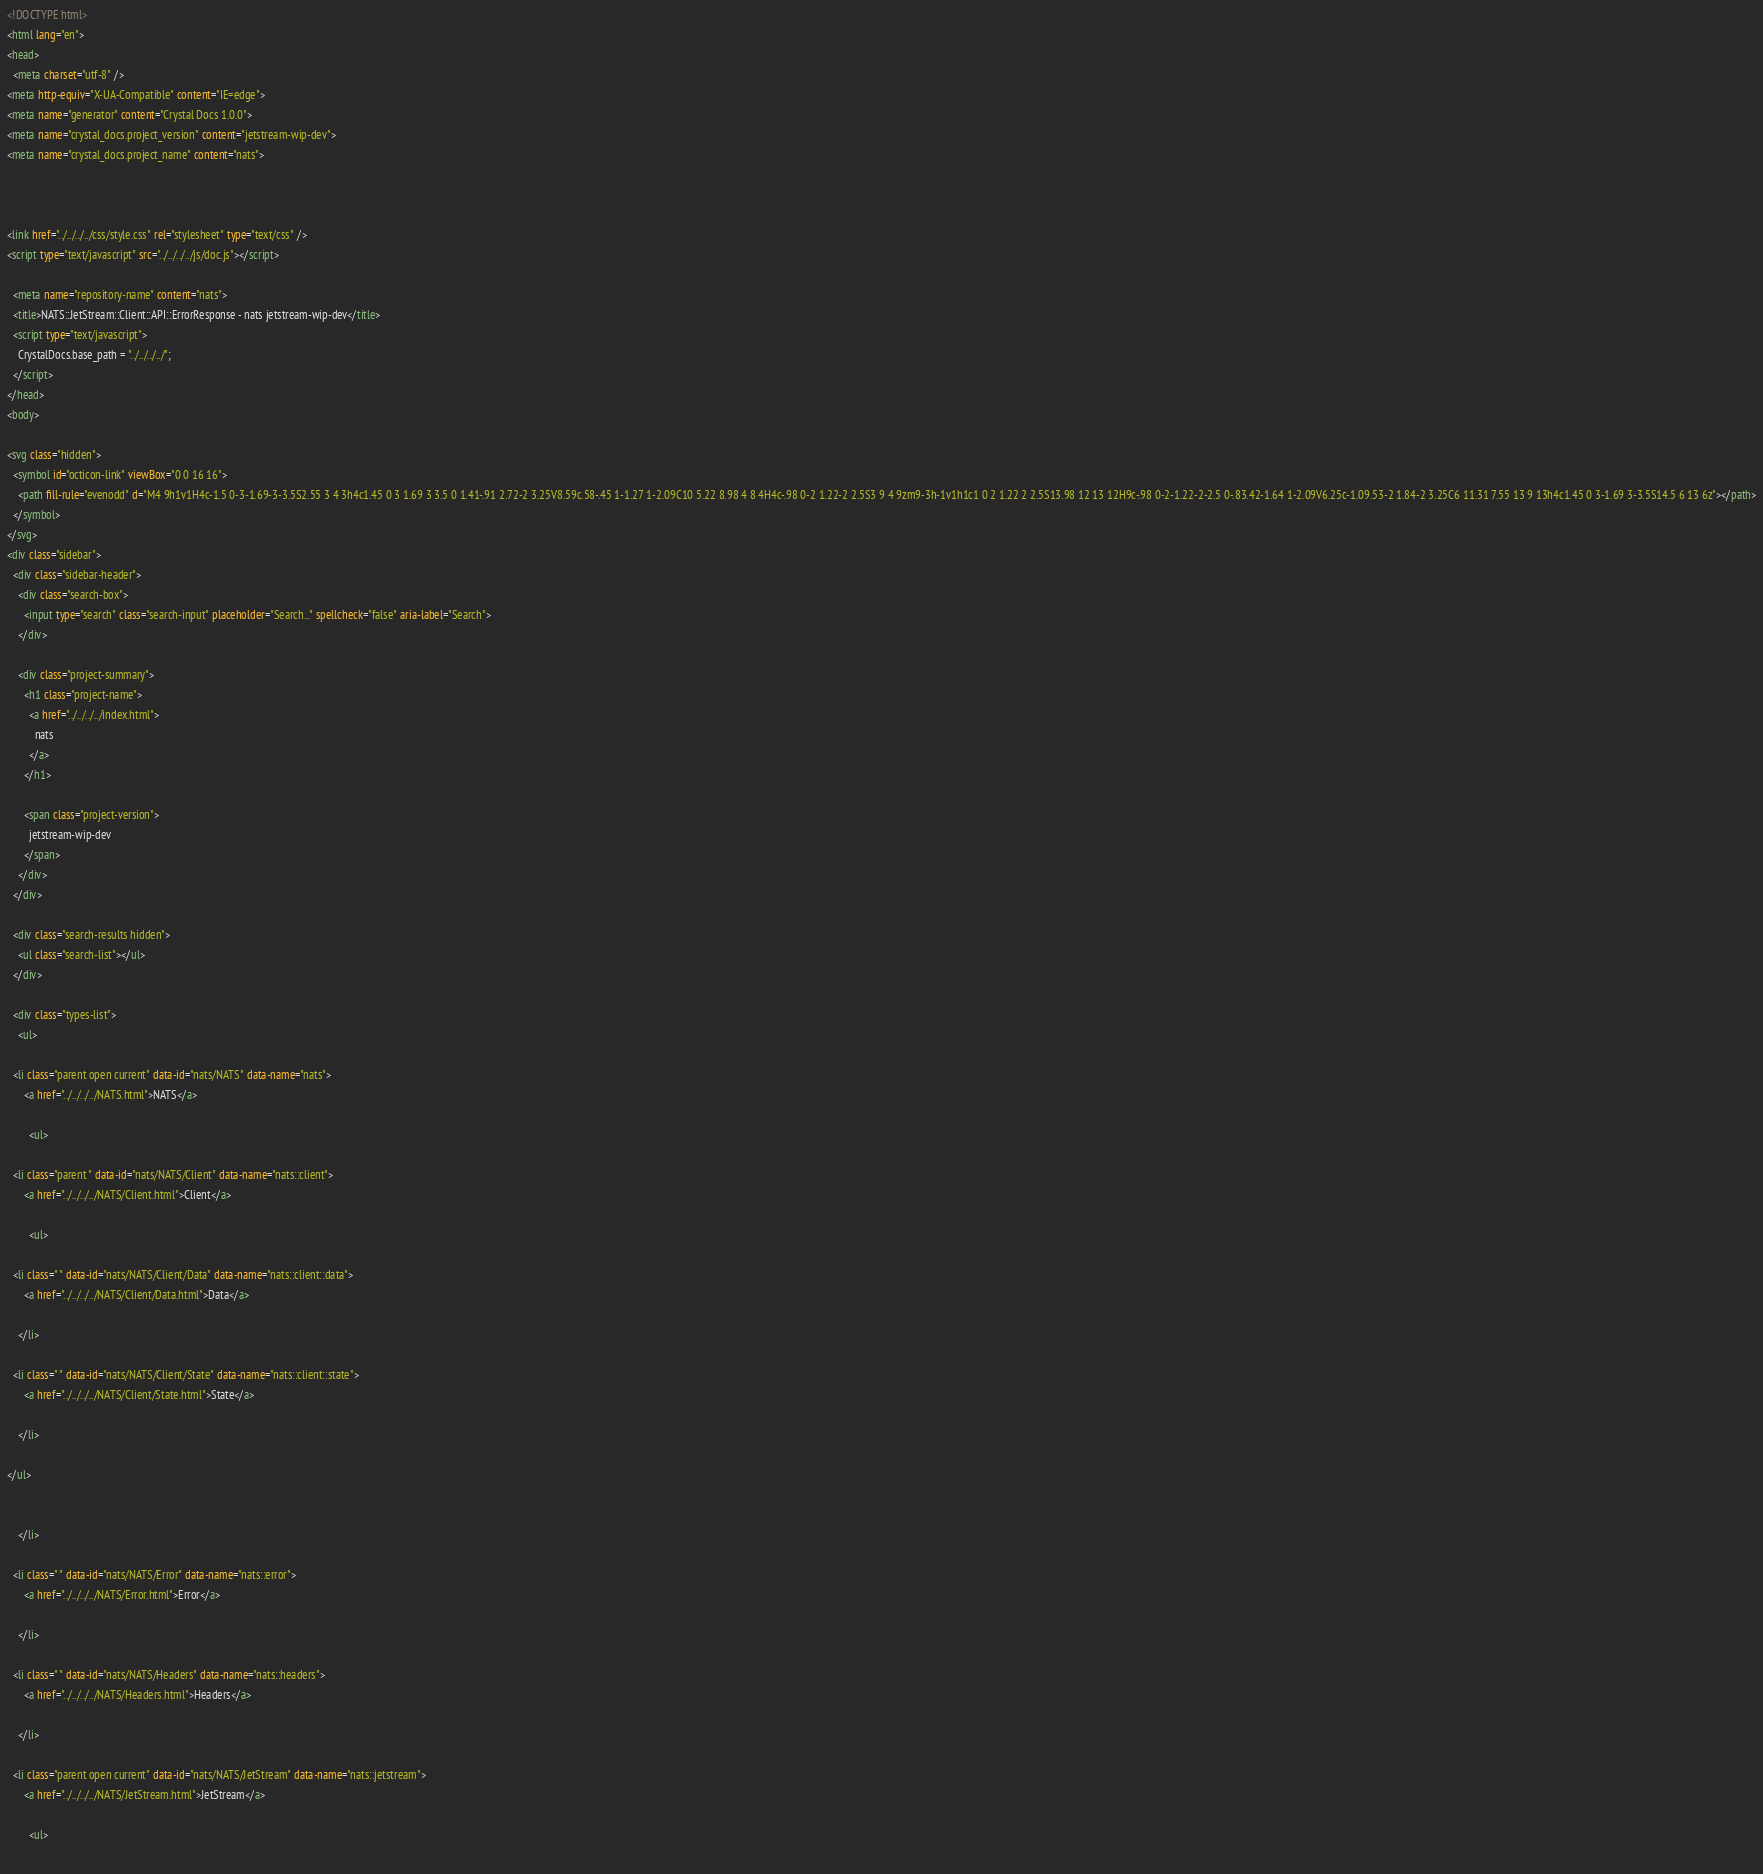Convert code to text. <code><loc_0><loc_0><loc_500><loc_500><_HTML_><!DOCTYPE html>
<html lang="en">
<head>
  <meta charset="utf-8" />
<meta http-equiv="X-UA-Compatible" content="IE=edge">
<meta name="generator" content="Crystal Docs 1.0.0">
<meta name="crystal_docs.project_version" content="jetstream-wip-dev">
<meta name="crystal_docs.project_name" content="nats">



<link href="../../../../css/style.css" rel="stylesheet" type="text/css" />
<script type="text/javascript" src="../../../../js/doc.js"></script>

  <meta name="repository-name" content="nats">
  <title>NATS::JetStream::Client::API::ErrorResponse - nats jetstream-wip-dev</title>
  <script type="text/javascript">
    CrystalDocs.base_path = "../../../../";
  </script>
</head>
<body>

<svg class="hidden">
  <symbol id="octicon-link" viewBox="0 0 16 16">
    <path fill-rule="evenodd" d="M4 9h1v1H4c-1.5 0-3-1.69-3-3.5S2.55 3 4 3h4c1.45 0 3 1.69 3 3.5 0 1.41-.91 2.72-2 3.25V8.59c.58-.45 1-1.27 1-2.09C10 5.22 8.98 4 8 4H4c-.98 0-2 1.22-2 2.5S3 9 4 9zm9-3h-1v1h1c1 0 2 1.22 2 2.5S13.98 12 13 12H9c-.98 0-2-1.22-2-2.5 0-.83.42-1.64 1-2.09V6.25c-1.09.53-2 1.84-2 3.25C6 11.31 7.55 13 9 13h4c1.45 0 3-1.69 3-3.5S14.5 6 13 6z"></path>
  </symbol>
</svg>
<div class="sidebar">
  <div class="sidebar-header">
    <div class="search-box">
      <input type="search" class="search-input" placeholder="Search..." spellcheck="false" aria-label="Search">
    </div>

    <div class="project-summary">
      <h1 class="project-name">
        <a href="../../../../index.html">
          nats
        </a>
      </h1>

      <span class="project-version">
        jetstream-wip-dev
      </span>
    </div>
  </div>

  <div class="search-results hidden">
    <ul class="search-list"></ul>
  </div>

  <div class="types-list">
    <ul>
  
  <li class="parent open current" data-id="nats/NATS" data-name="nats">
      <a href="../../../../NATS.html">NATS</a>
      
        <ul>
  
  <li class="parent " data-id="nats/NATS/Client" data-name="nats::client">
      <a href="../../../../NATS/Client.html">Client</a>
      
        <ul>
  
  <li class=" " data-id="nats/NATS/Client/Data" data-name="nats::client::data">
      <a href="../../../../NATS/Client/Data.html">Data</a>
      
    </li>
  
  <li class=" " data-id="nats/NATS/Client/State" data-name="nats::client::state">
      <a href="../../../../NATS/Client/State.html">State</a>
      
    </li>
  
</ul>

      
    </li>
  
  <li class=" " data-id="nats/NATS/Error" data-name="nats::error">
      <a href="../../../../NATS/Error.html">Error</a>
      
    </li>
  
  <li class=" " data-id="nats/NATS/Headers" data-name="nats::headers">
      <a href="../../../../NATS/Headers.html">Headers</a>
      
    </li>
  
  <li class="parent open current" data-id="nats/NATS/JetStream" data-name="nats::jetstream">
      <a href="../../../../NATS/JetStream.html">JetStream</a>
      
        <ul>
  </code> 